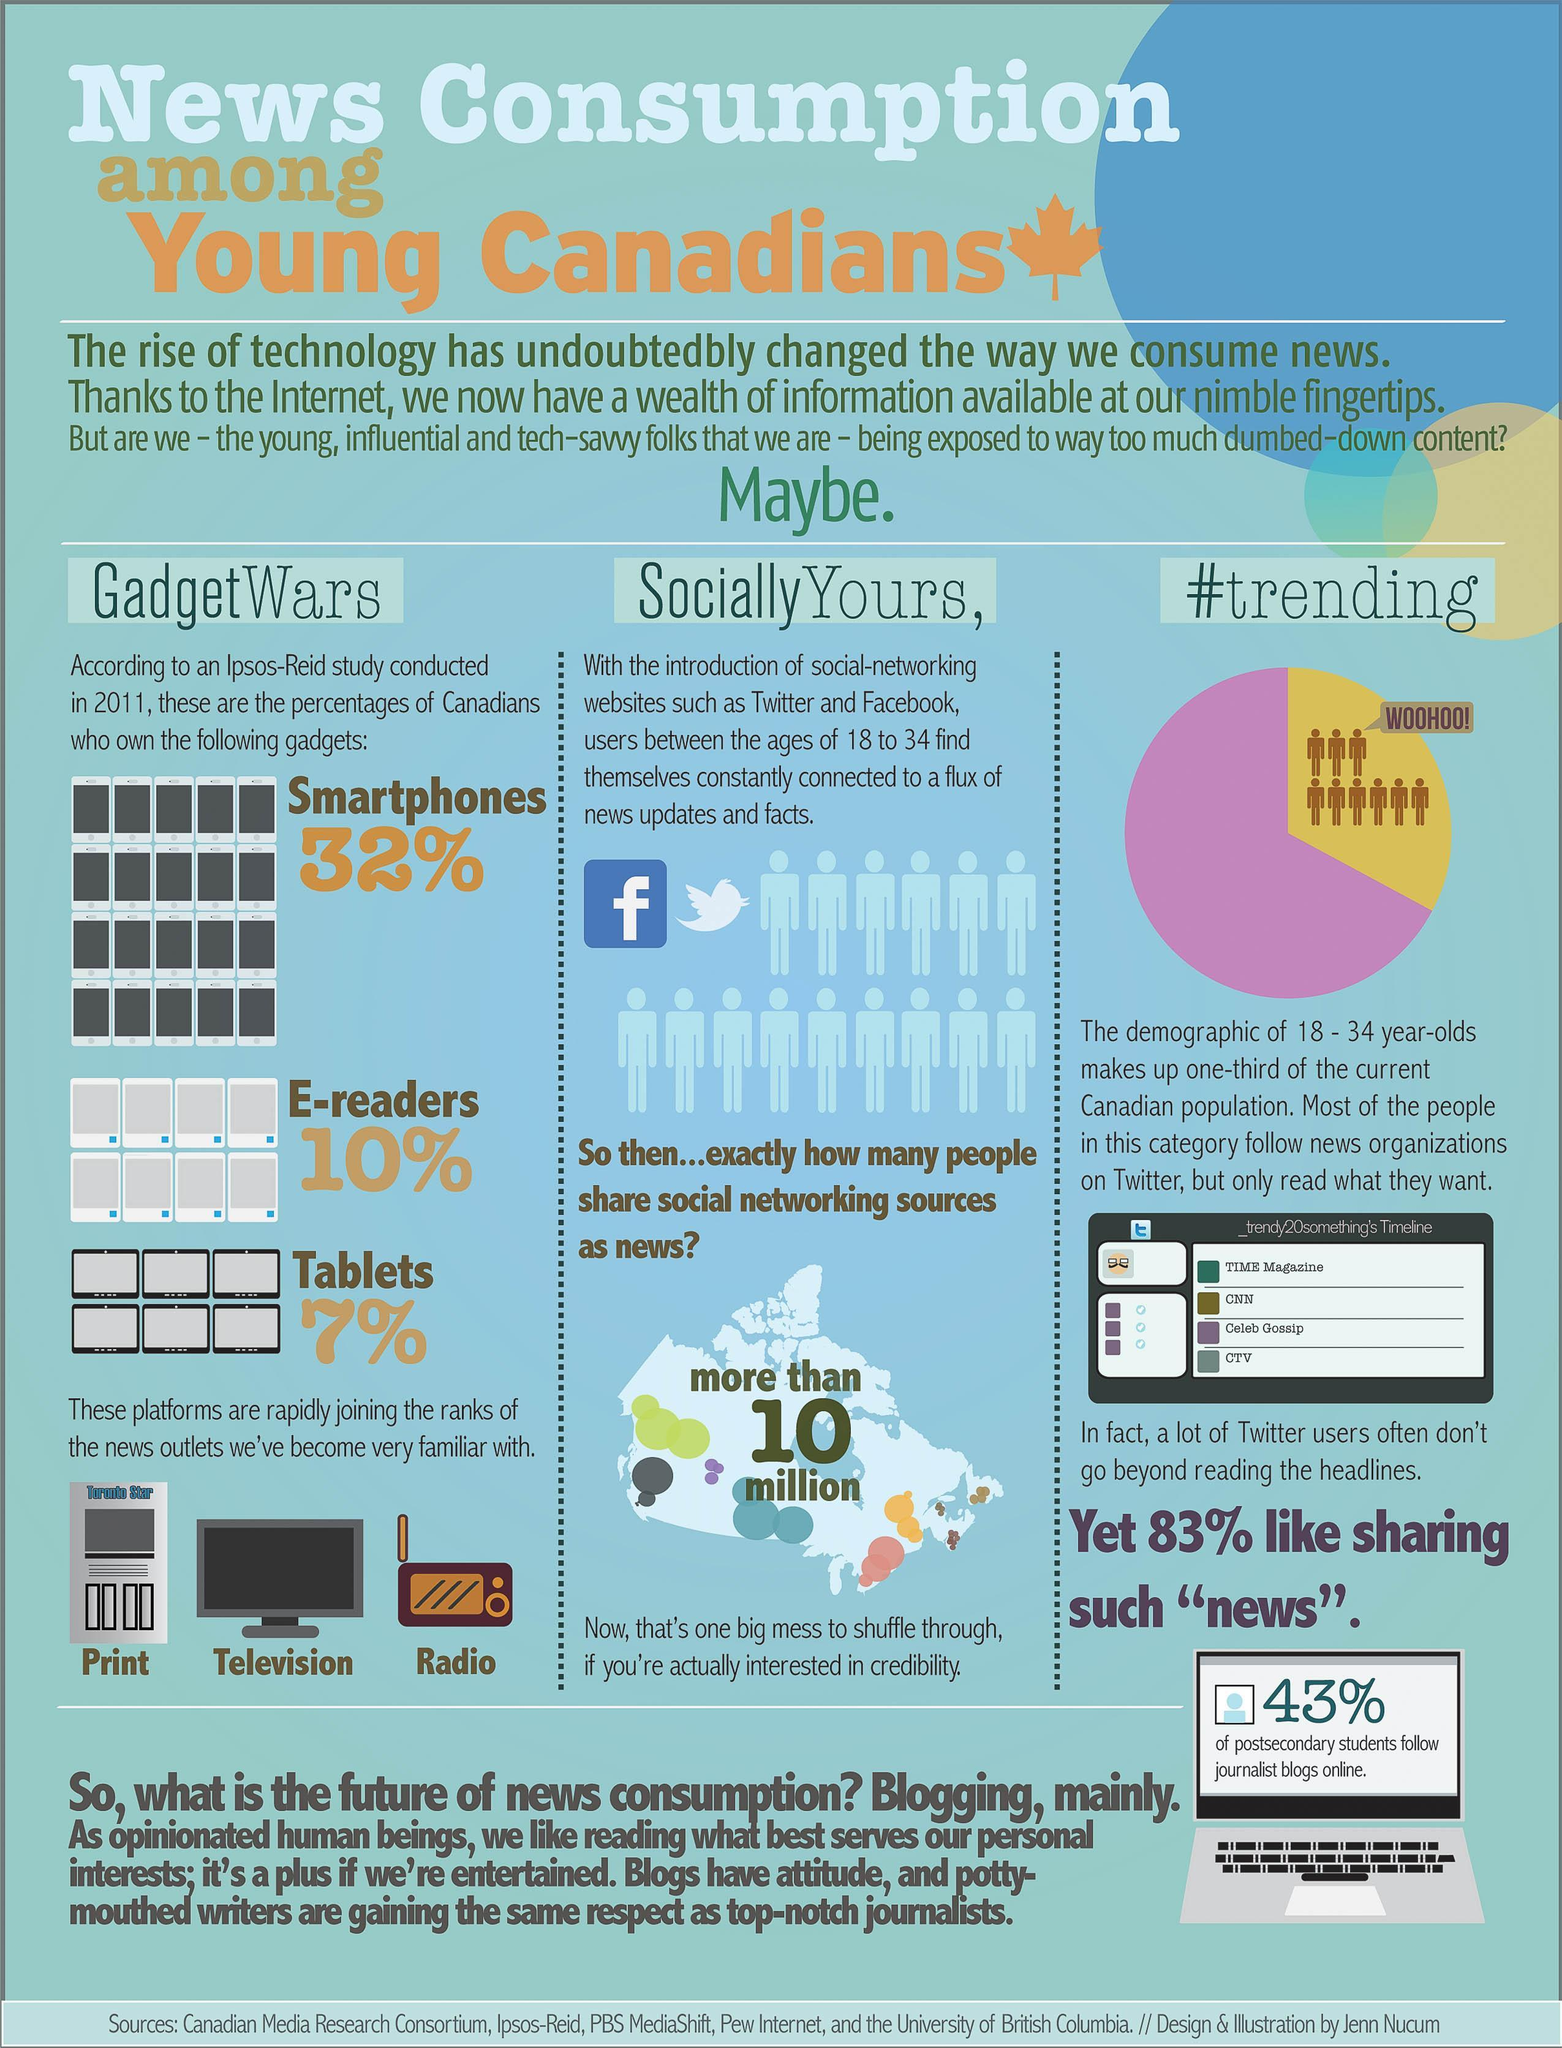How many people share social networking sources as news
Answer the question with a short phrase. more than 10 million What are joining ranks with print, television and radio smartphones, e-readers, tablets what are the news outlets we've become very familiar with print, television, radio What is written as comment on the yellow section of the pie chart woohoo! What % of Canadians own E-readers 10% What do 32% of canadians own smartphones 